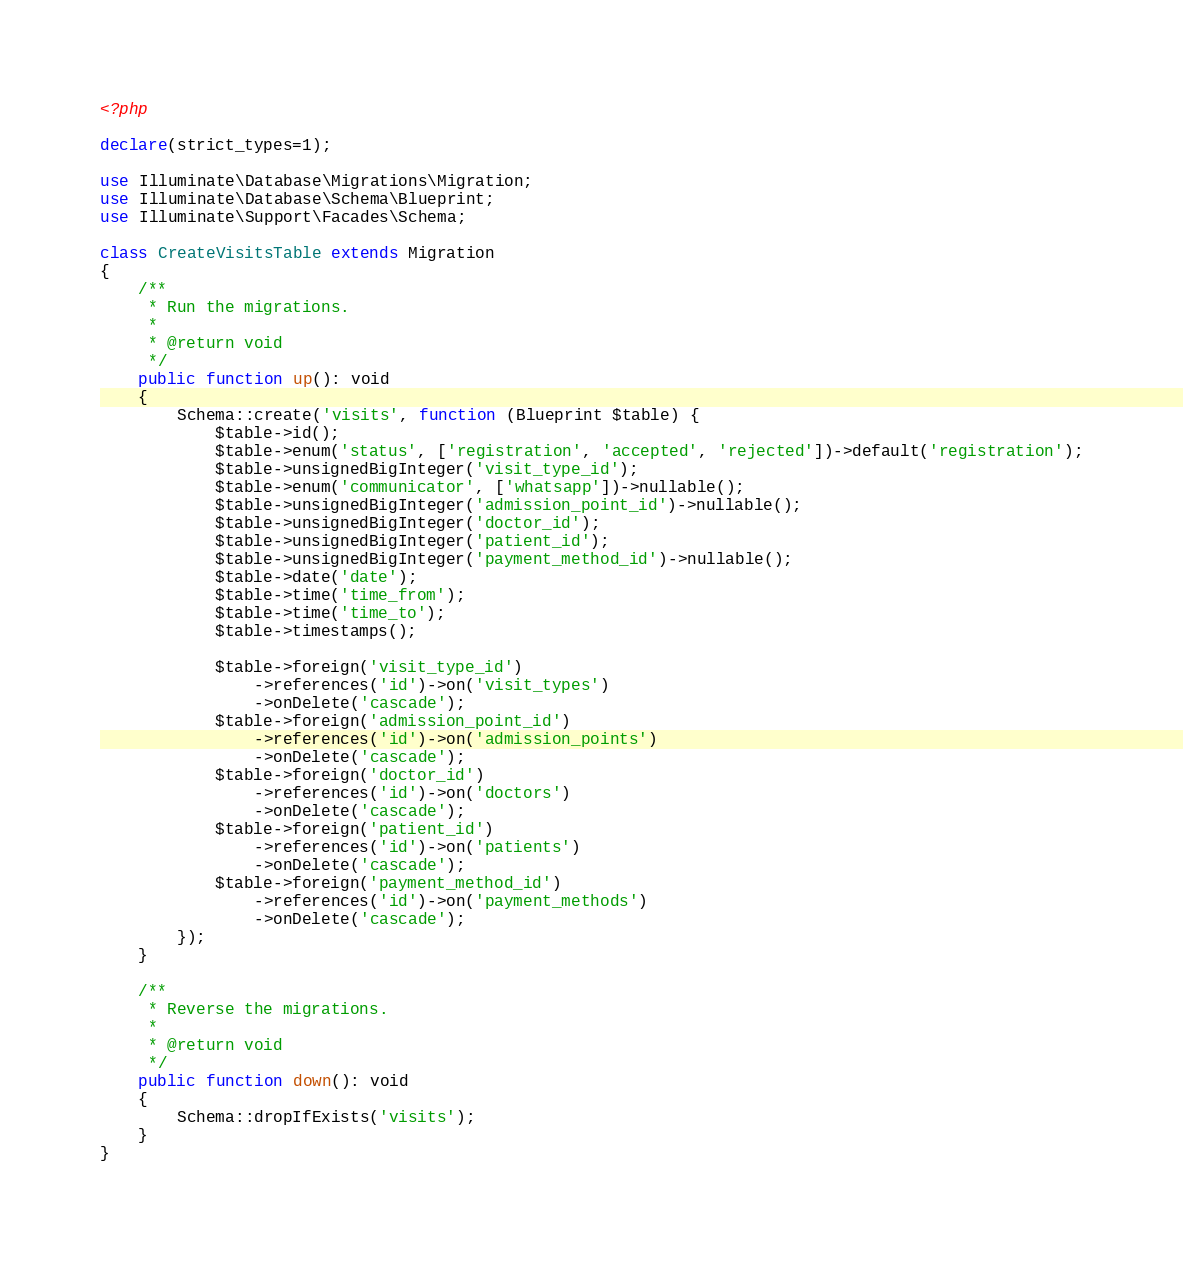Convert code to text. <code><loc_0><loc_0><loc_500><loc_500><_PHP_><?php

declare(strict_types=1);

use Illuminate\Database\Migrations\Migration;
use Illuminate\Database\Schema\Blueprint;
use Illuminate\Support\Facades\Schema;

class CreateVisitsTable extends Migration
{
    /**
     * Run the migrations.
     *
     * @return void
     */
    public function up(): void
    {
        Schema::create('visits', function (Blueprint $table) {
            $table->id();
            $table->enum('status', ['registration', 'accepted', 'rejected'])->default('registration');
            $table->unsignedBigInteger('visit_type_id');
            $table->enum('communicator', ['whatsapp'])->nullable();
            $table->unsignedBigInteger('admission_point_id')->nullable();
            $table->unsignedBigInteger('doctor_id');
            $table->unsignedBigInteger('patient_id');
            $table->unsignedBigInteger('payment_method_id')->nullable();
            $table->date('date');
            $table->time('time_from');
            $table->time('time_to');
            $table->timestamps();

            $table->foreign('visit_type_id')
                ->references('id')->on('visit_types')
                ->onDelete('cascade');
            $table->foreign('admission_point_id')
                ->references('id')->on('admission_points')
                ->onDelete('cascade');
            $table->foreign('doctor_id')
                ->references('id')->on('doctors')
                ->onDelete('cascade');
            $table->foreign('patient_id')
                ->references('id')->on('patients')
                ->onDelete('cascade');
            $table->foreign('payment_method_id')
                ->references('id')->on('payment_methods')
                ->onDelete('cascade');
        });
    }

    /**
     * Reverse the migrations.
     *
     * @return void
     */
    public function down(): void
    {
        Schema::dropIfExists('visits');
    }
}
</code> 